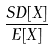Convert formula to latex. <formula><loc_0><loc_0><loc_500><loc_500>\frac { S D [ X ] } { E [ X ] }</formula> 